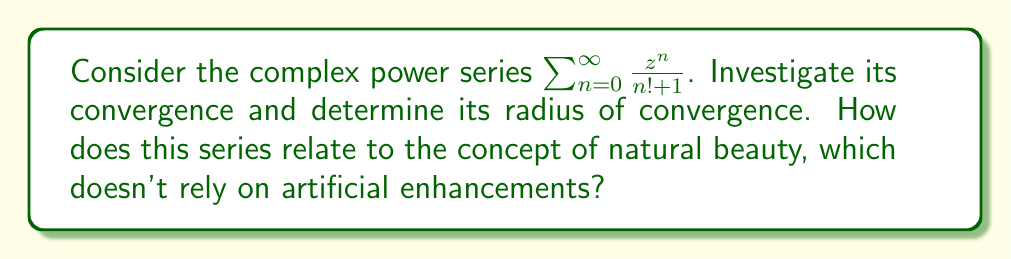Can you answer this question? Let's approach this step-by-step:

1) To determine the radius of convergence, we can use the ratio test. Let $a_n = \frac{1}{n! + 1}$, so our series is $\sum_{n=0}^{\infty} a_n z^n$.

2) We calculate the limit:

   $$\lim_{n \to \infty} \left|\frac{a_{n+1}}{a_n}\right| = \lim_{n \to \infty} \left|\frac{n! + 1}{(n+1)! + 1}\right|$$

3) Simplify:
   $$\lim_{n \to \infty} \left|\frac{n! + 1}{(n+1)(n! + 1)}\right| = \lim_{n \to \infty} \left|\frac{1}{n+1}\right| = 0$$

4) The ratio test states that if this limit is less than 1, the series converges for all $z$. Since our limit is 0, which is indeed less than 1, the series converges for all complex $z$.

5) Therefore, the radius of convergence is infinite, or $R = \infty$.

6) This means the series converges absolutely for all complex numbers.

Relating to the concept of natural beauty:
Just as this series converges naturally for all values without any restrictions or artificial limits, natural beauty shines through without the need for artificial enhancements. The infinite radius of convergence can be seen as a metaphor for the boundless nature of inner beauty, which isn't confined by external factors.
Answer: The complex power series $\sum_{n=0}^{\infty} \frac{z^n}{n! + 1}$ converges absolutely for all complex numbers $z$. Its radius of convergence is $R = \infty$. 